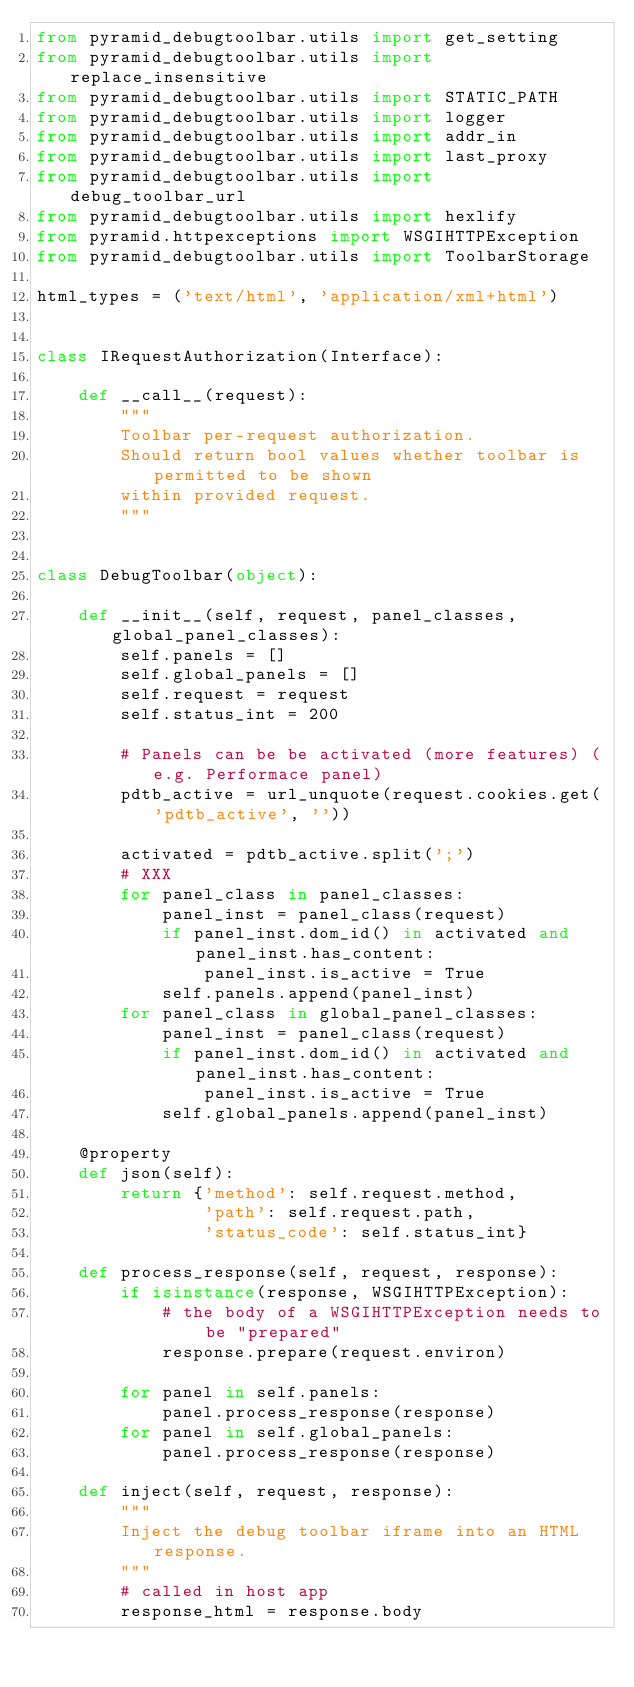Convert code to text. <code><loc_0><loc_0><loc_500><loc_500><_Python_>from pyramid_debugtoolbar.utils import get_setting
from pyramid_debugtoolbar.utils import replace_insensitive
from pyramid_debugtoolbar.utils import STATIC_PATH
from pyramid_debugtoolbar.utils import logger
from pyramid_debugtoolbar.utils import addr_in
from pyramid_debugtoolbar.utils import last_proxy
from pyramid_debugtoolbar.utils import debug_toolbar_url
from pyramid_debugtoolbar.utils import hexlify
from pyramid.httpexceptions import WSGIHTTPException
from pyramid_debugtoolbar.utils import ToolbarStorage

html_types = ('text/html', 'application/xml+html')


class IRequestAuthorization(Interface):

    def __call__(request):
        """
        Toolbar per-request authorization.
        Should return bool values whether toolbar is permitted to be shown
        within provided request.
        """


class DebugToolbar(object):

    def __init__(self, request, panel_classes, global_panel_classes):
        self.panels = []
        self.global_panels = []
        self.request = request
        self.status_int = 200

        # Panels can be be activated (more features) (e.g. Performace panel)
        pdtb_active = url_unquote(request.cookies.get('pdtb_active', ''))

        activated = pdtb_active.split(';')
        # XXX
        for panel_class in panel_classes:
            panel_inst = panel_class(request)
            if panel_inst.dom_id() in activated and panel_inst.has_content:
                panel_inst.is_active = True
            self.panels.append(panel_inst)
        for panel_class in global_panel_classes:
            panel_inst = panel_class(request)
            if panel_inst.dom_id() in activated and panel_inst.has_content:
                panel_inst.is_active = True
            self.global_panels.append(panel_inst)

    @property
    def json(self):
        return {'method': self.request.method,
                'path': self.request.path,
                'status_code': self.status_int}

    def process_response(self, request, response):
        if isinstance(response, WSGIHTTPException):
            # the body of a WSGIHTTPException needs to be "prepared"
            response.prepare(request.environ)

        for panel in self.panels:
            panel.process_response(response)
        for panel in self.global_panels:
            panel.process_response(response)

    def inject(self, request, response):
        """
        Inject the debug toolbar iframe into an HTML response.
        """
        # called in host app
        response_html = response.body</code> 